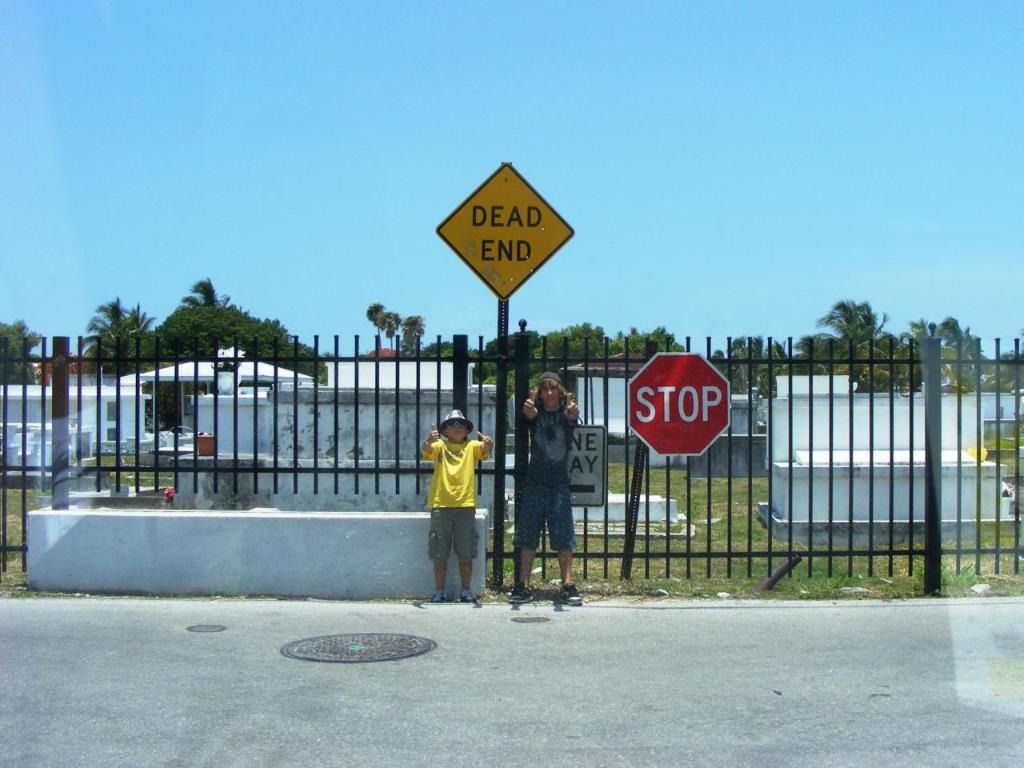<image>
Write a terse but informative summary of the picture. Two people gives the thumbs up posing for a picture under a sign that says Dead end. 